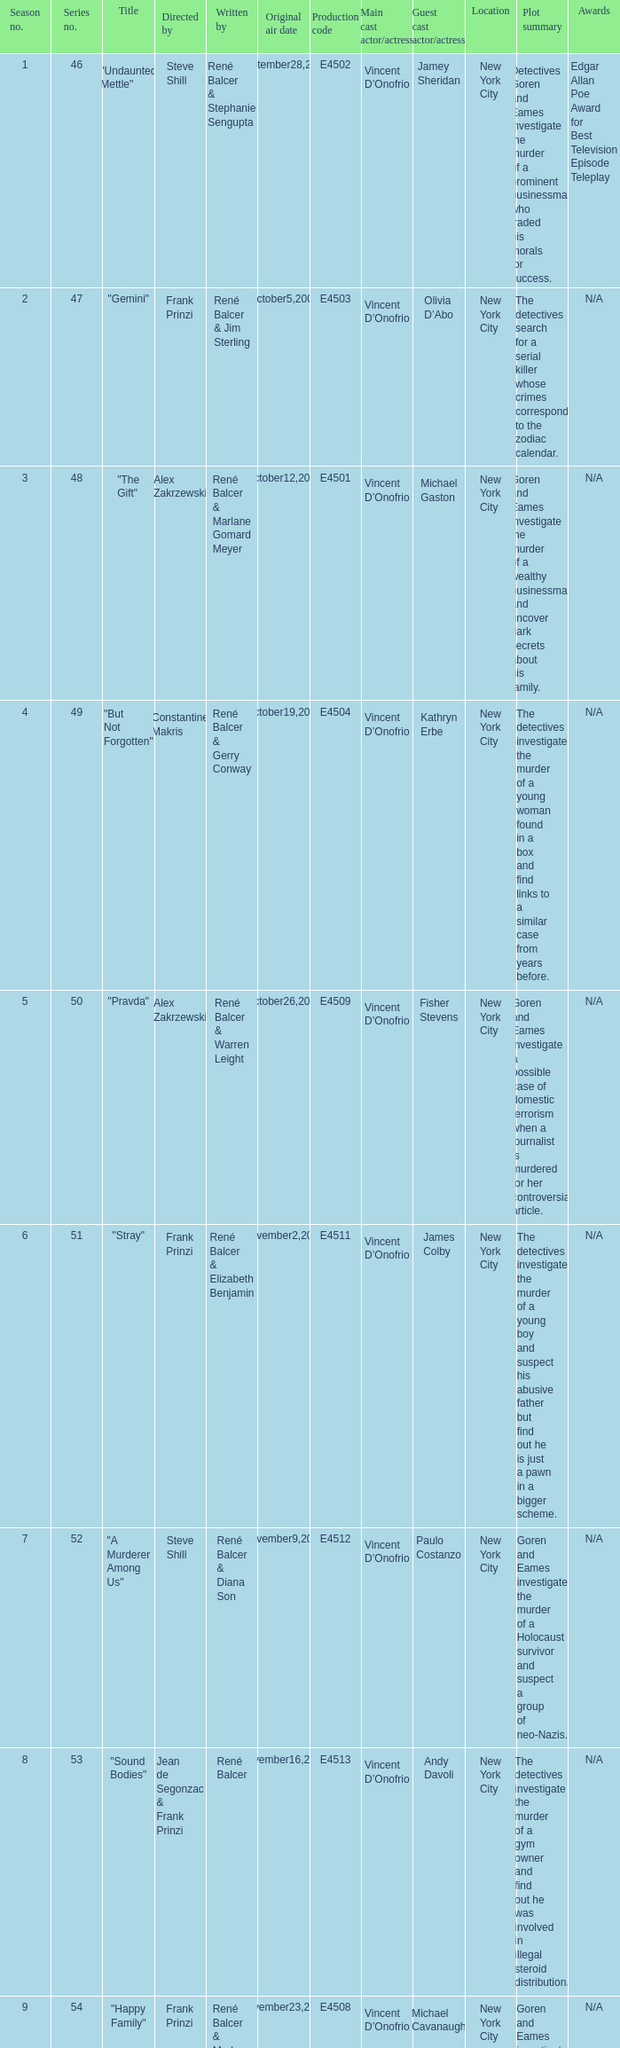What date did "d.a.w." Originally air? May16,2004. 